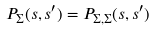<formula> <loc_0><loc_0><loc_500><loc_500>P _ { \Sigma } ( s , s ^ { \prime } ) = P _ { \Sigma , \Sigma } ( s , s ^ { \prime } )</formula> 